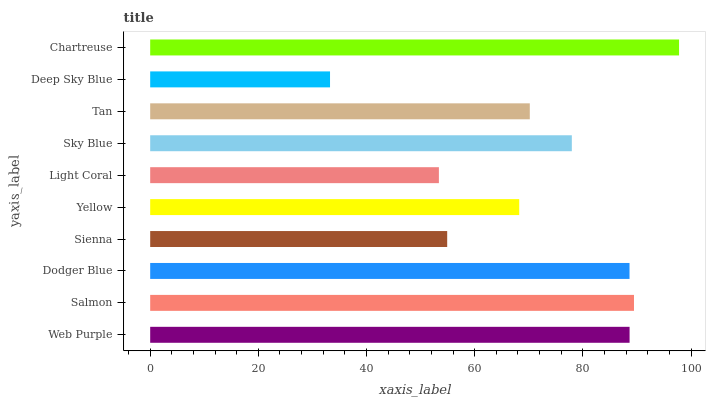Is Deep Sky Blue the minimum?
Answer yes or no. Yes. Is Chartreuse the maximum?
Answer yes or no. Yes. Is Salmon the minimum?
Answer yes or no. No. Is Salmon the maximum?
Answer yes or no. No. Is Salmon greater than Web Purple?
Answer yes or no. Yes. Is Web Purple less than Salmon?
Answer yes or no. Yes. Is Web Purple greater than Salmon?
Answer yes or no. No. Is Salmon less than Web Purple?
Answer yes or no. No. Is Sky Blue the high median?
Answer yes or no. Yes. Is Tan the low median?
Answer yes or no. Yes. Is Chartreuse the high median?
Answer yes or no. No. Is Web Purple the low median?
Answer yes or no. No. 